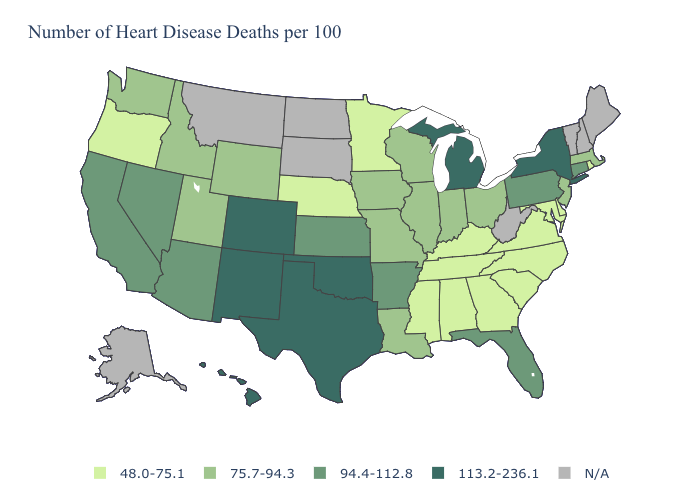What is the lowest value in the USA?
Short answer required. 48.0-75.1. Which states hav the highest value in the Northeast?
Short answer required. New York. Name the states that have a value in the range 48.0-75.1?
Be succinct. Alabama, Delaware, Georgia, Kentucky, Maryland, Minnesota, Mississippi, Nebraska, North Carolina, Oregon, Rhode Island, South Carolina, Tennessee, Virginia. What is the value of Kentucky?
Keep it brief. 48.0-75.1. What is the value of Kentucky?
Answer briefly. 48.0-75.1. What is the lowest value in the South?
Keep it brief. 48.0-75.1. Name the states that have a value in the range 113.2-236.1?
Short answer required. Colorado, Hawaii, Michigan, New Mexico, New York, Oklahoma, Texas. Does California have the highest value in the West?
Answer briefly. No. Does New York have the highest value in the Northeast?
Write a very short answer. Yes. Name the states that have a value in the range 113.2-236.1?
Quick response, please. Colorado, Hawaii, Michigan, New Mexico, New York, Oklahoma, Texas. Name the states that have a value in the range 113.2-236.1?
Short answer required. Colorado, Hawaii, Michigan, New Mexico, New York, Oklahoma, Texas. Name the states that have a value in the range 113.2-236.1?
Write a very short answer. Colorado, Hawaii, Michigan, New Mexico, New York, Oklahoma, Texas. Which states have the lowest value in the USA?
Quick response, please. Alabama, Delaware, Georgia, Kentucky, Maryland, Minnesota, Mississippi, Nebraska, North Carolina, Oregon, Rhode Island, South Carolina, Tennessee, Virginia. 